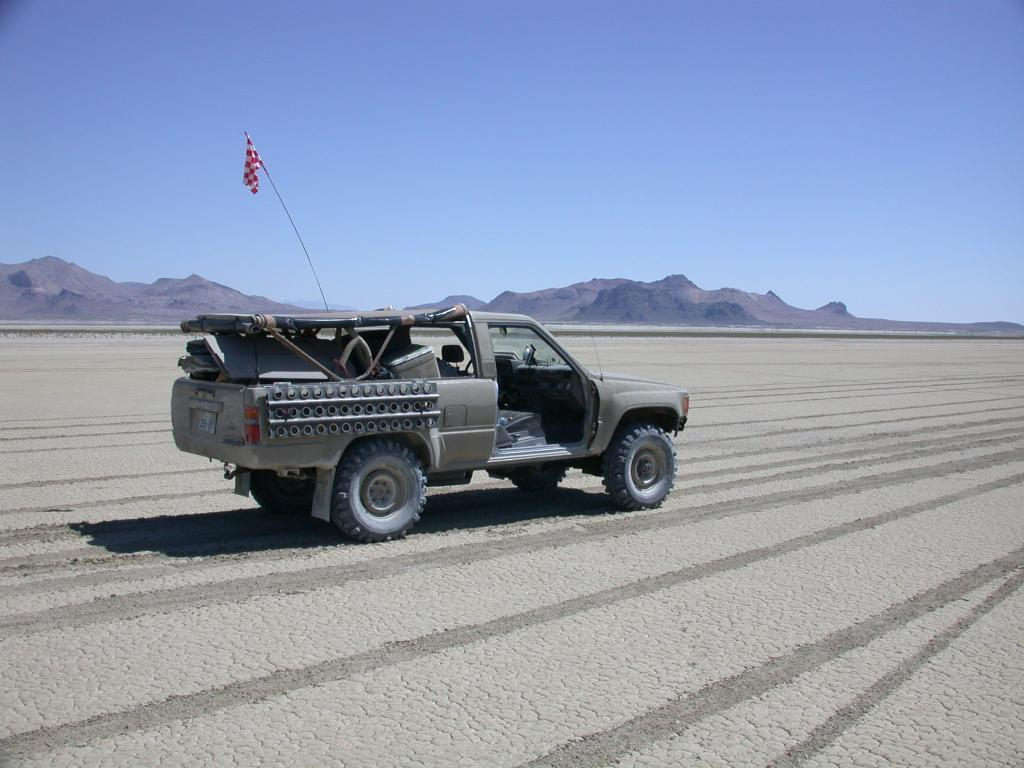What is the main subject of the image? The main subject of the image is a truck. Where is the truck located in the image? The truck is on the ground in the image. What is attached to the truck? There is a flag on the truck. What can be seen in the background of the image? Hills are visible in the background of the image. How would you describe the sky in the image? The sky is clear in the image. What type of structure is being crushed by the truck in the image? There is no structure being crushed by the truck in the image; the truck is simply on the ground with a flag attached to it. 